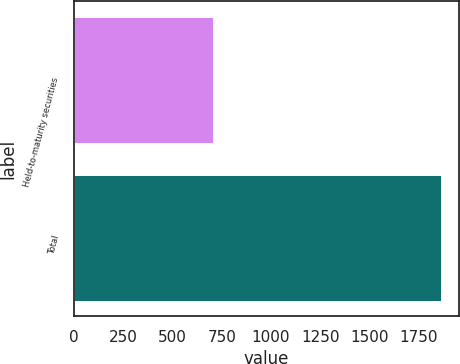Convert chart. <chart><loc_0><loc_0><loc_500><loc_500><bar_chart><fcel>Held-to-maturity securities<fcel>Total<nl><fcel>705<fcel>1862<nl></chart> 